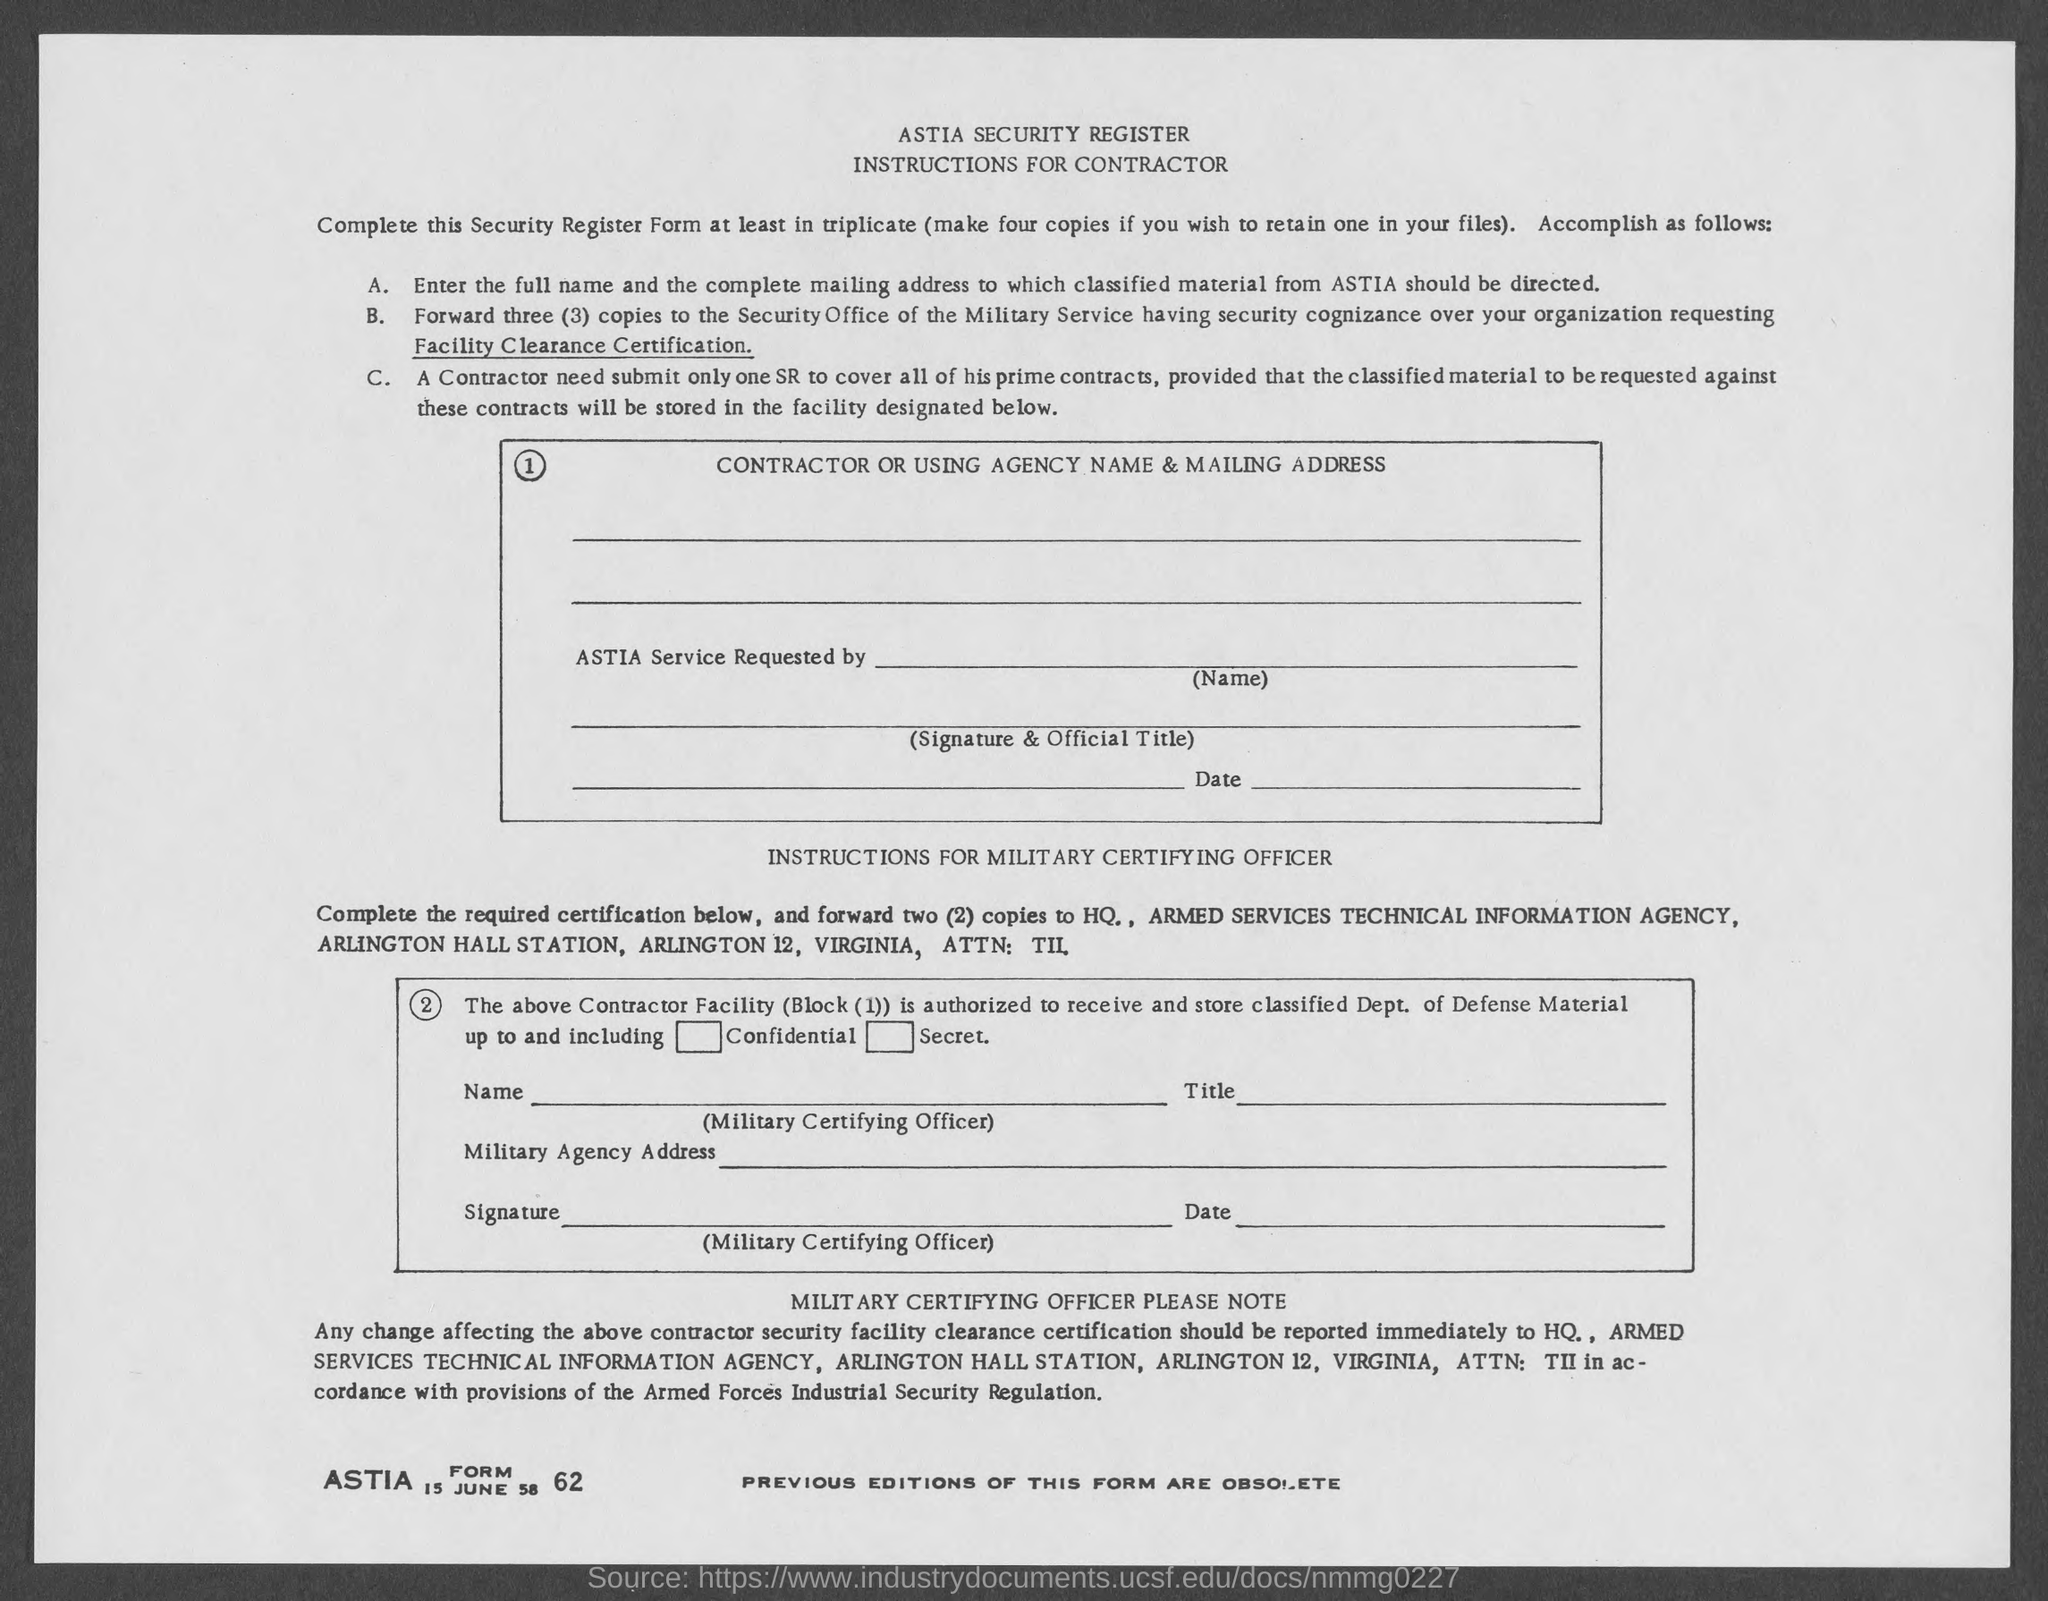What is the ASTIA Form No. given?
Offer a terse response. 62. What is the date mentioned in the form?
Your answer should be compact. 15 JUNE 58. 